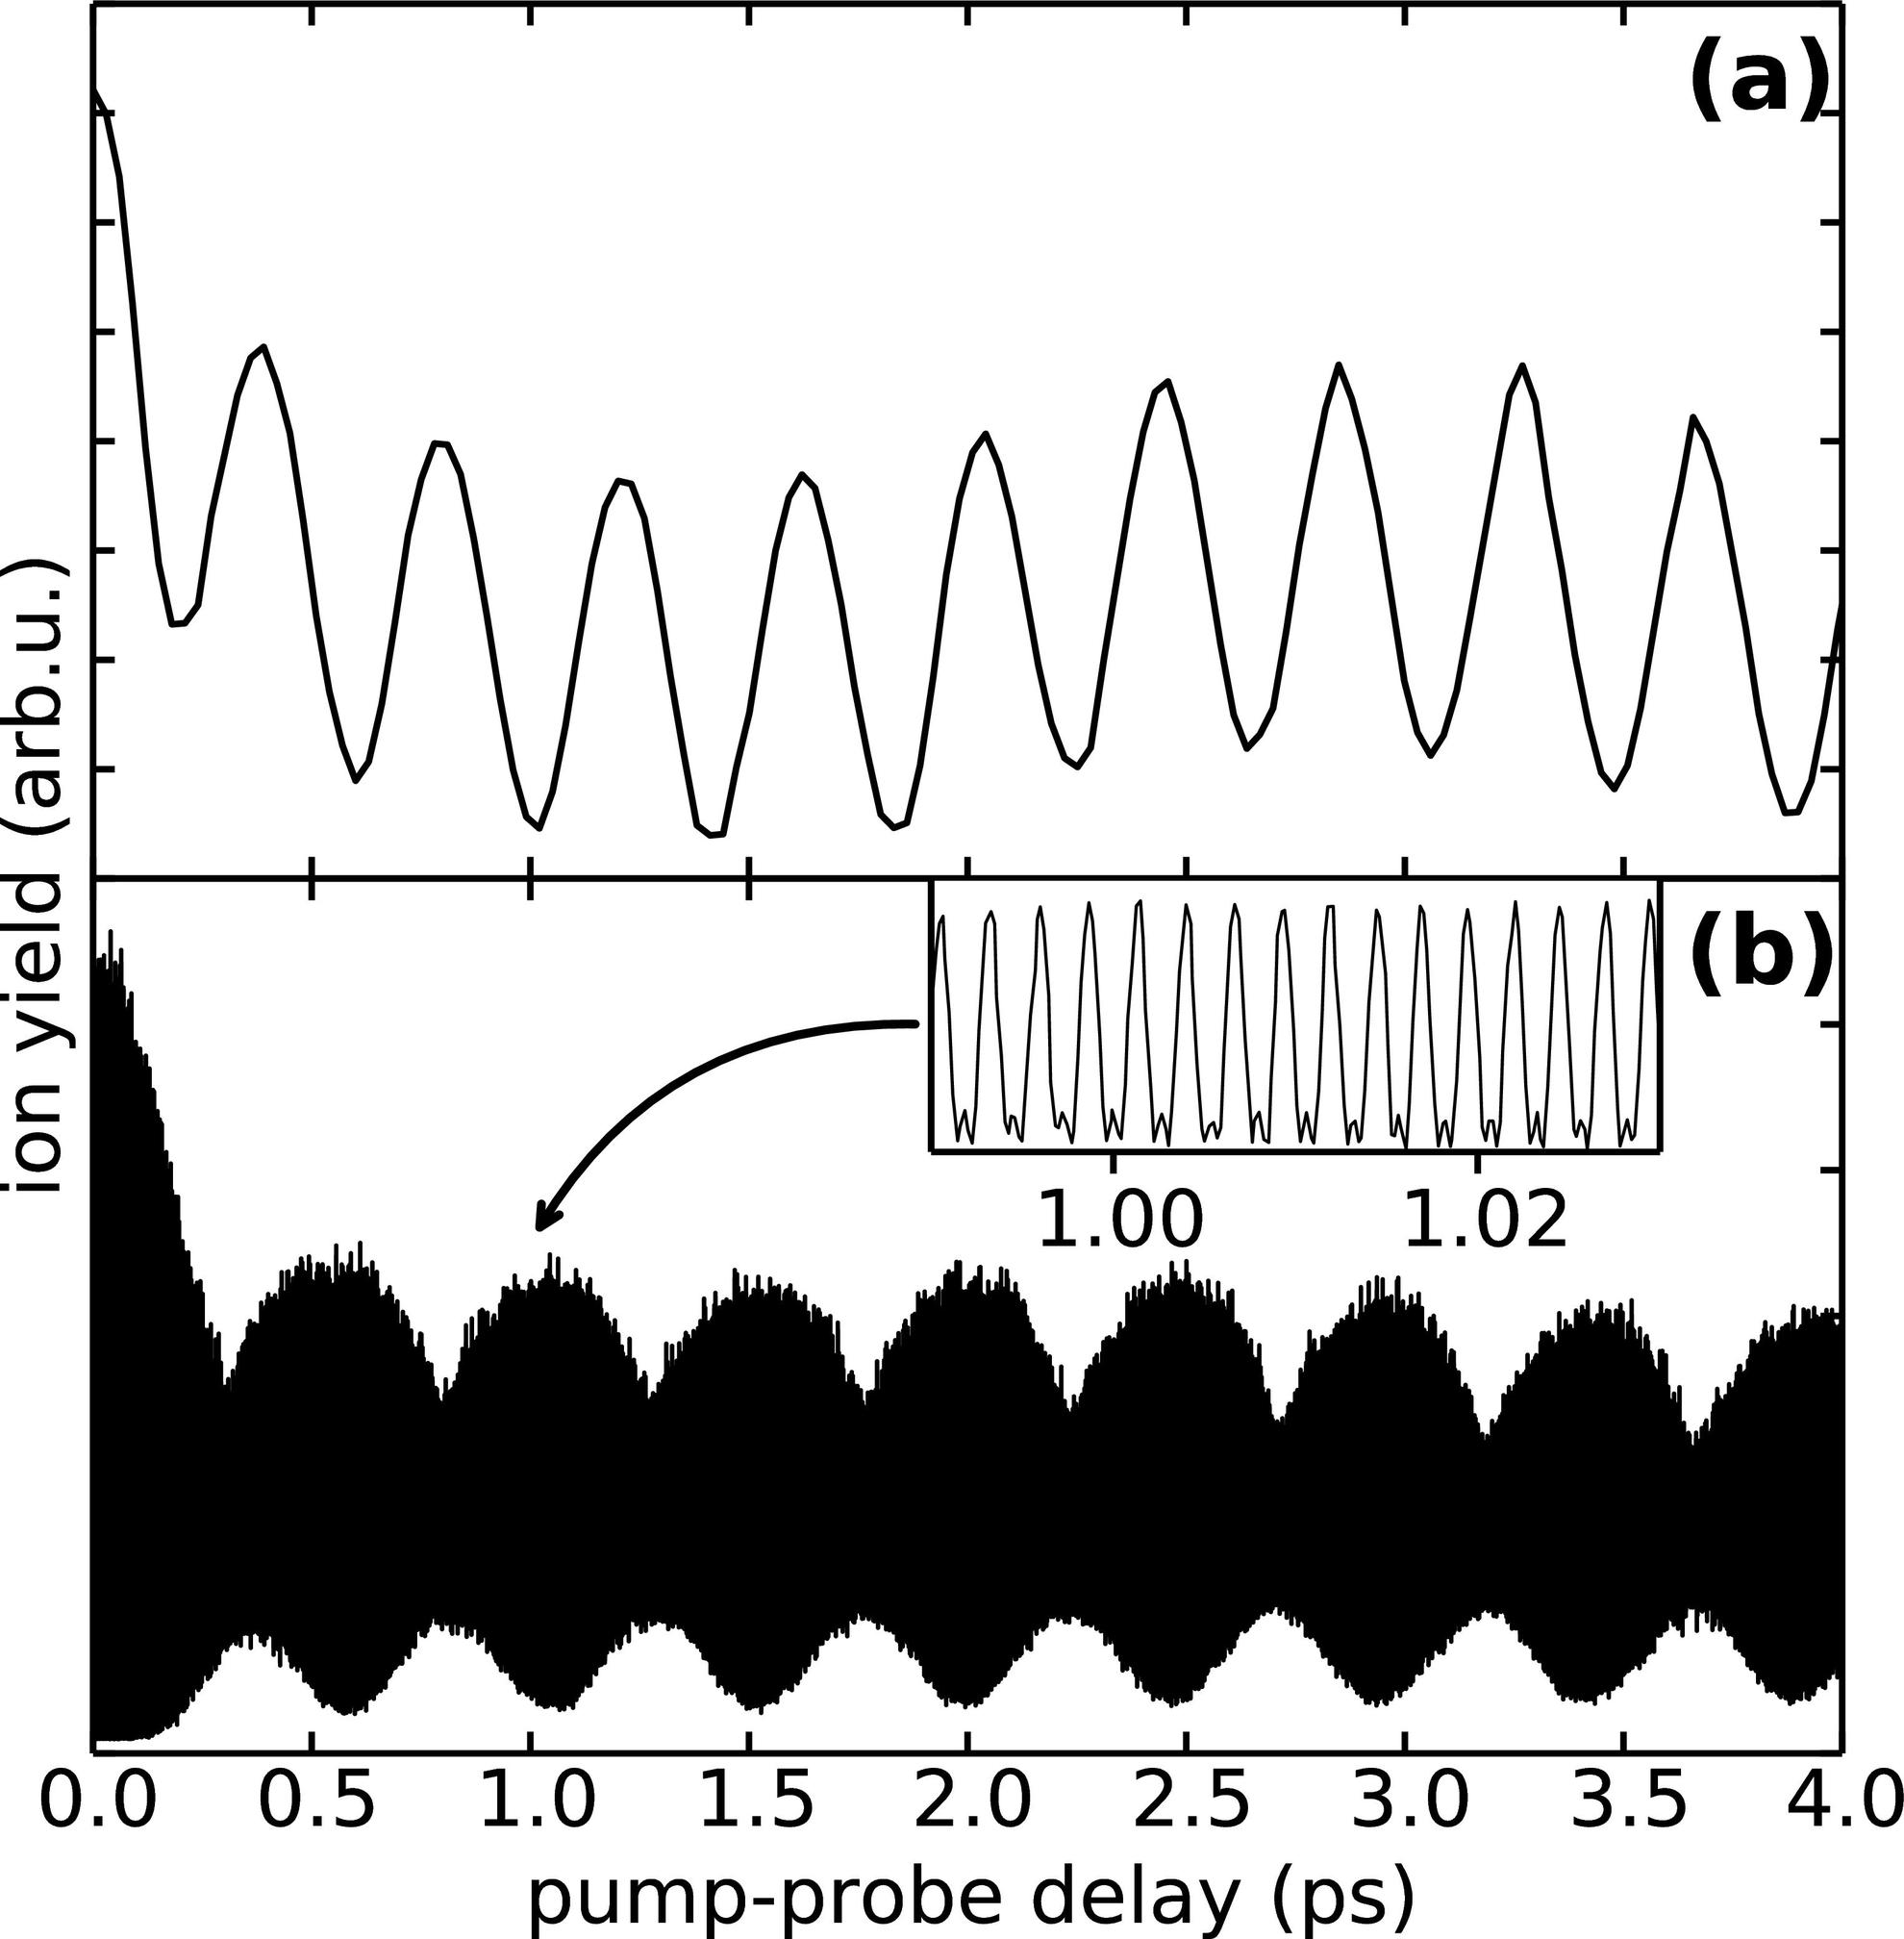Can you describe the overall trend in panel (a) and explain its significance? Panel (a) displays a sinusoidal oscillation pattern over a pump-probe delay range of 0 to 4 ps. These oscillations likely represent periodic variations in ion yield as a function of the probe delay, possibly indicating coherent vibrational dynamics in the system. Understanding these patterns is pivotal as they can provide insights into the energy states and transition dynamics of molecules or materials under study. 